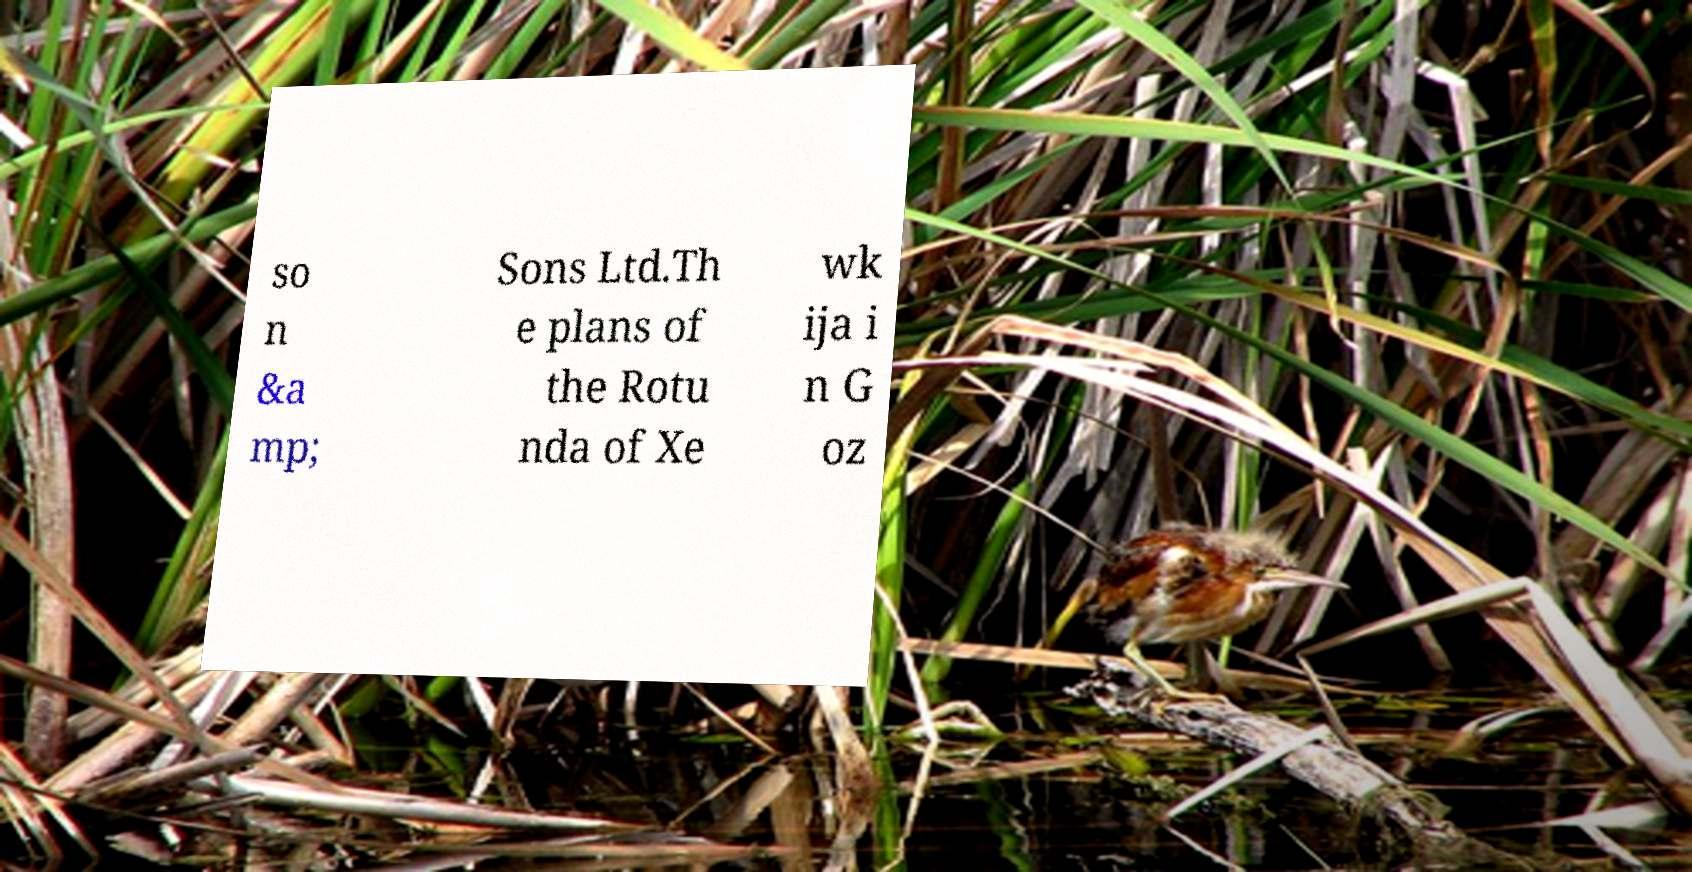There's text embedded in this image that I need extracted. Can you transcribe it verbatim? so n &a mp; Sons Ltd.Th e plans of the Rotu nda of Xe wk ija i n G oz 